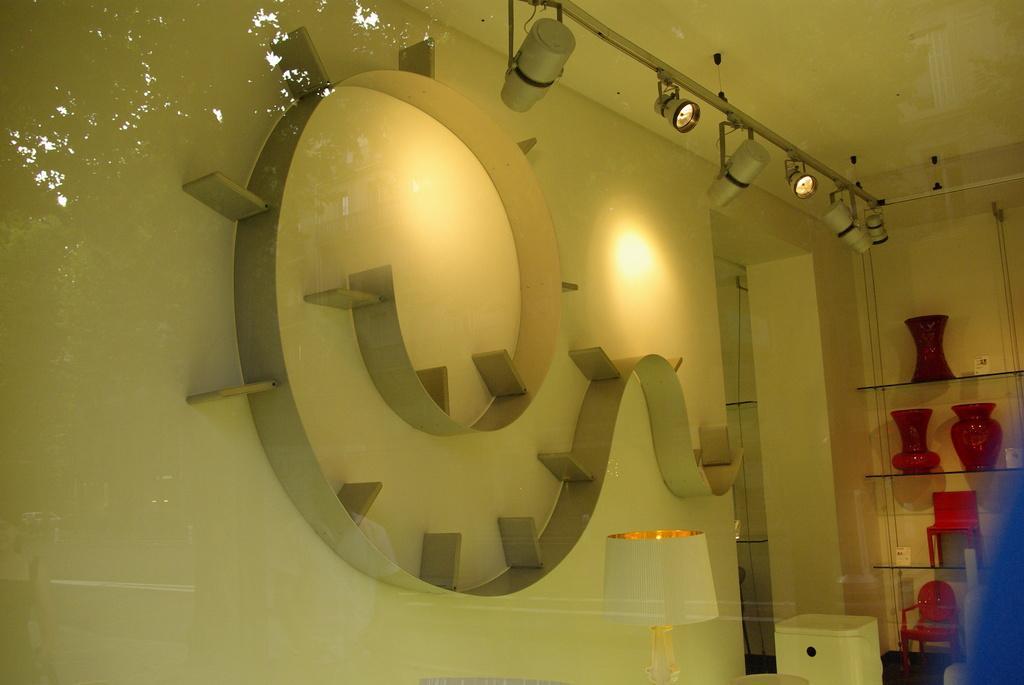Describe this image in one or two sentences. In this image we can see the interior view of the room where there is some architecture on the wall, few lights hanging from the roof, a light on one of the tables and some objects arranged on the shelves. 